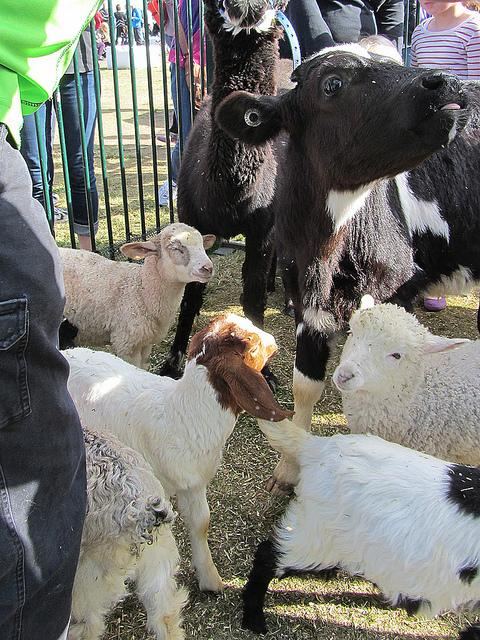What does the girl come to this venue for? Please explain your reasoning. petting animals. These are docile animals you can get close to 